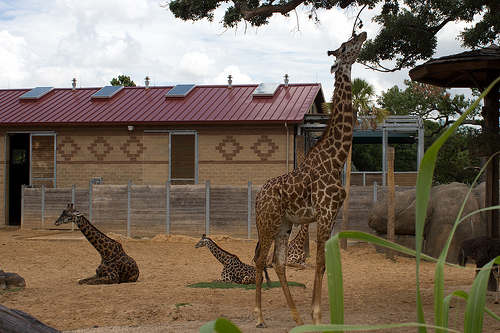Please provide the bounding box coordinate of the region this sentence describes: A large wooden fence. The coordinates for the bounding box around a large wooden fence are [0.03, 0.53, 0.5, 0.64]. 